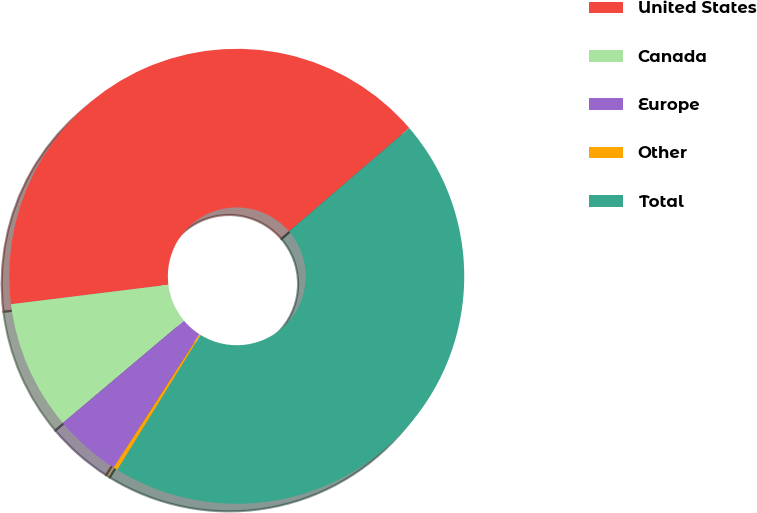Convert chart to OTSL. <chart><loc_0><loc_0><loc_500><loc_500><pie_chart><fcel>United States<fcel>Canada<fcel>Europe<fcel>Other<fcel>Total<nl><fcel>40.66%<fcel>9.19%<fcel>4.75%<fcel>0.3%<fcel>45.1%<nl></chart> 